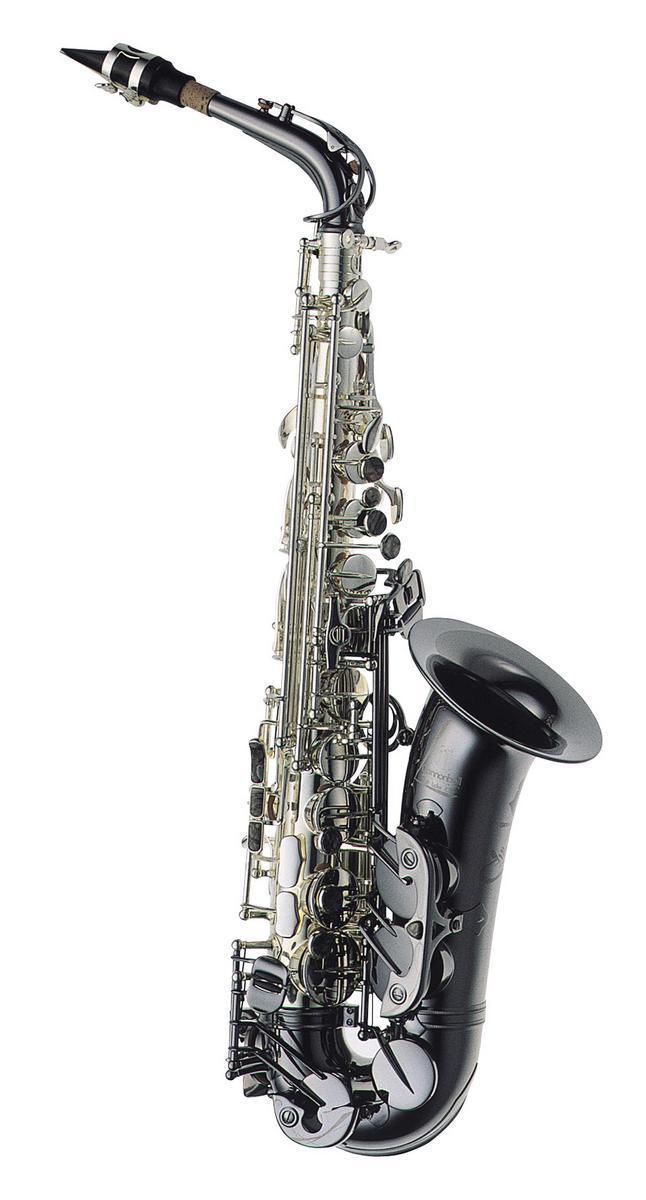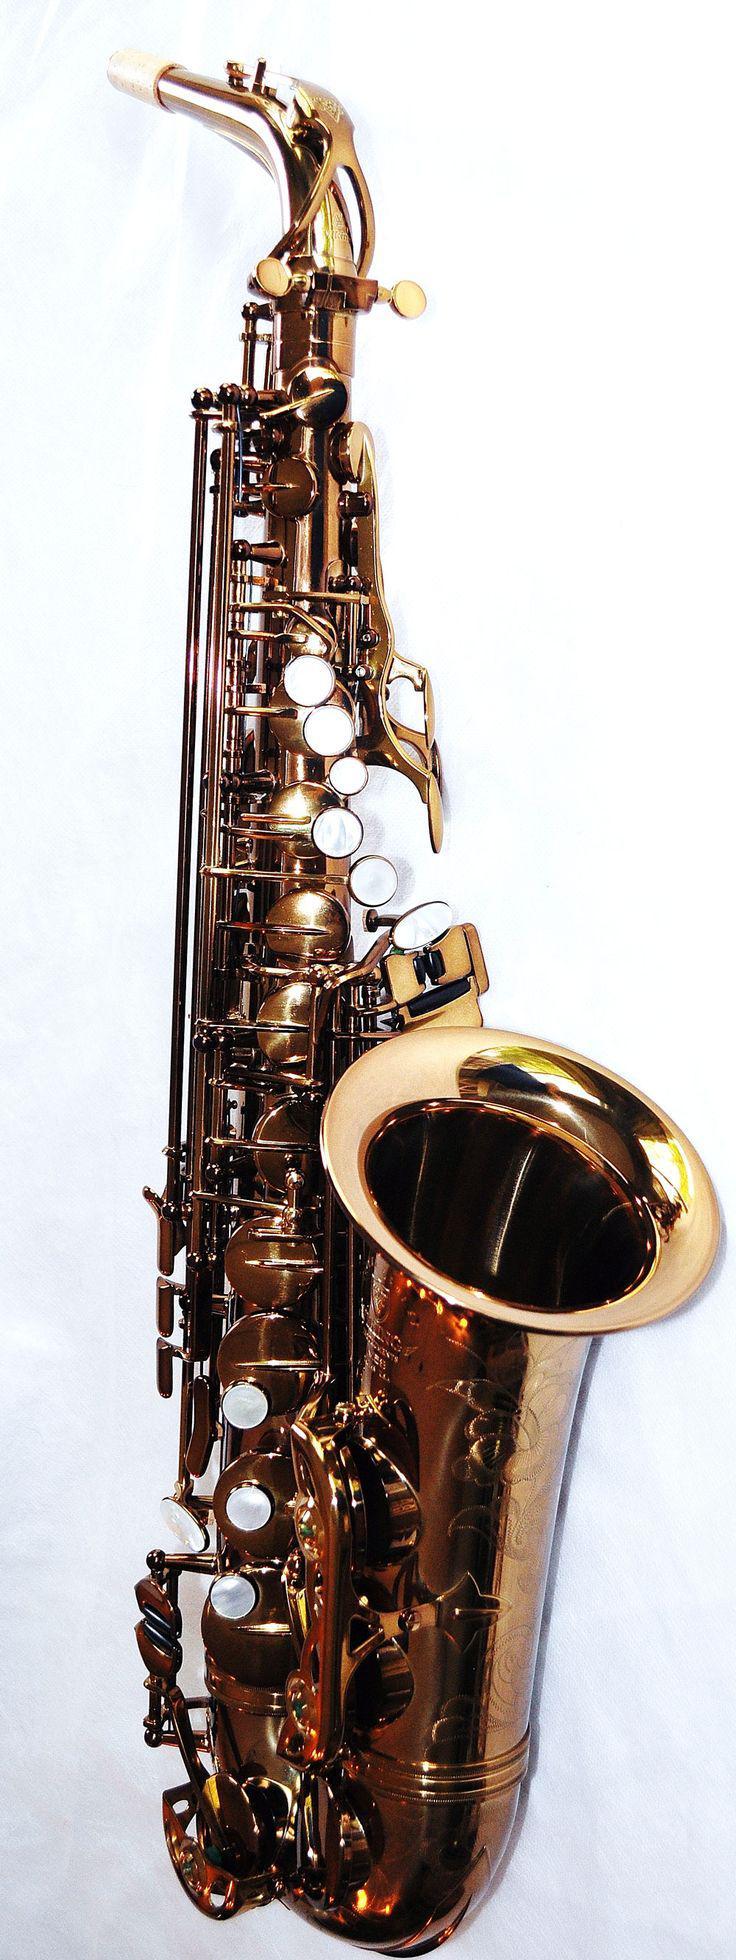The first image is the image on the left, the second image is the image on the right. For the images shown, is this caption "The left image shows one saxophone displayed upright with its bell facing right, and the right image shows decorative etching embellishing the bell-end of a saxophone." true? Answer yes or no. No. The first image is the image on the left, the second image is the image on the right. Considering the images on both sides, is "The mouthpiece is visible in both images." valid? Answer yes or no. Yes. 